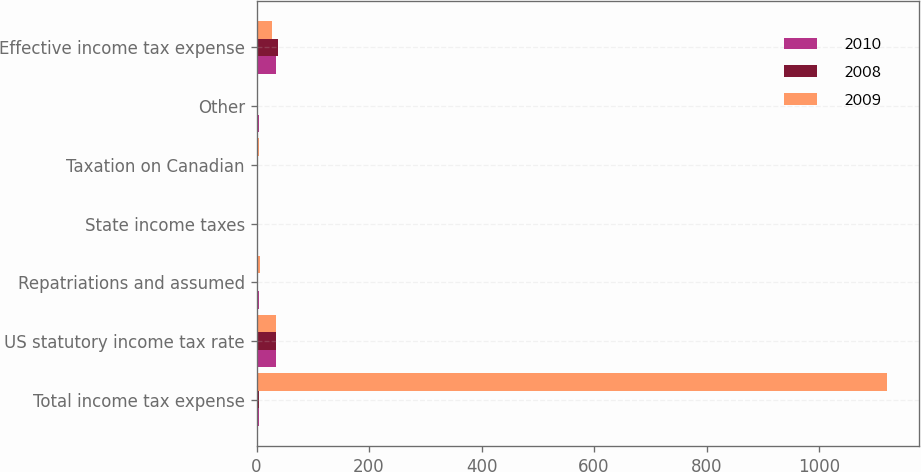Convert chart. <chart><loc_0><loc_0><loc_500><loc_500><stacked_bar_chart><ecel><fcel>Total income tax expense<fcel>US statutory income tax rate<fcel>Repatriations and assumed<fcel>State income taxes<fcel>Taxation on Canadian<fcel>Other<fcel>Effective income tax expense<nl><fcel>2010<fcel>4<fcel>35<fcel>4<fcel>1<fcel>1<fcel>4<fcel>35<nl><fcel>2008<fcel>4<fcel>35<fcel>1<fcel>2<fcel>1<fcel>2<fcel>39<nl><fcel>2009<fcel>1121<fcel>35<fcel>7<fcel>1<fcel>5<fcel>3<fcel>27<nl></chart> 